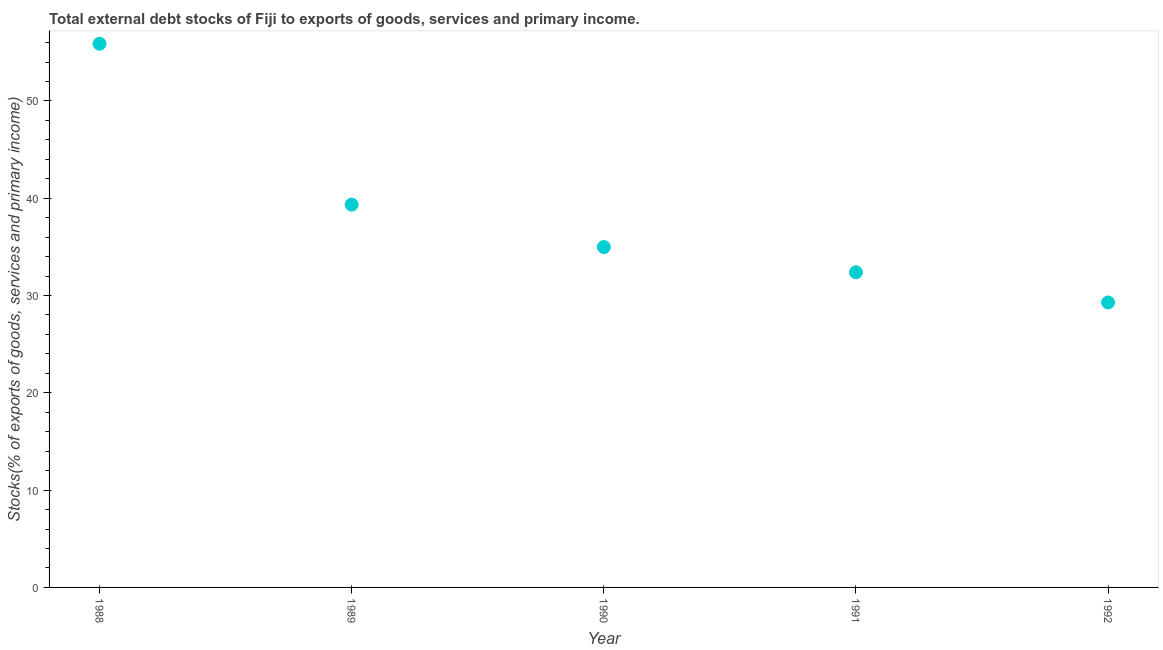What is the external debt stocks in 1989?
Provide a short and direct response. 39.34. Across all years, what is the maximum external debt stocks?
Ensure brevity in your answer.  55.88. Across all years, what is the minimum external debt stocks?
Provide a succinct answer. 29.29. In which year was the external debt stocks maximum?
Provide a succinct answer. 1988. In which year was the external debt stocks minimum?
Offer a very short reply. 1992. What is the sum of the external debt stocks?
Give a very brief answer. 191.88. What is the difference between the external debt stocks in 1991 and 1992?
Provide a succinct answer. 3.1. What is the average external debt stocks per year?
Your answer should be compact. 38.38. What is the median external debt stocks?
Your answer should be very brief. 34.98. In how many years, is the external debt stocks greater than 42 %?
Your answer should be very brief. 1. Do a majority of the years between 1991 and 1988 (inclusive) have external debt stocks greater than 22 %?
Give a very brief answer. Yes. What is the ratio of the external debt stocks in 1988 to that in 1991?
Your answer should be compact. 1.73. What is the difference between the highest and the second highest external debt stocks?
Provide a short and direct response. 16.53. Is the sum of the external debt stocks in 1990 and 1991 greater than the maximum external debt stocks across all years?
Your answer should be very brief. Yes. What is the difference between the highest and the lowest external debt stocks?
Offer a very short reply. 26.59. In how many years, is the external debt stocks greater than the average external debt stocks taken over all years?
Provide a short and direct response. 2. What is the difference between two consecutive major ticks on the Y-axis?
Offer a terse response. 10. Are the values on the major ticks of Y-axis written in scientific E-notation?
Make the answer very short. No. Does the graph contain any zero values?
Provide a succinct answer. No. What is the title of the graph?
Your answer should be compact. Total external debt stocks of Fiji to exports of goods, services and primary income. What is the label or title of the X-axis?
Give a very brief answer. Year. What is the label or title of the Y-axis?
Your response must be concise. Stocks(% of exports of goods, services and primary income). What is the Stocks(% of exports of goods, services and primary income) in 1988?
Offer a very short reply. 55.88. What is the Stocks(% of exports of goods, services and primary income) in 1989?
Offer a terse response. 39.34. What is the Stocks(% of exports of goods, services and primary income) in 1990?
Provide a short and direct response. 34.98. What is the Stocks(% of exports of goods, services and primary income) in 1991?
Offer a very short reply. 32.39. What is the Stocks(% of exports of goods, services and primary income) in 1992?
Offer a terse response. 29.29. What is the difference between the Stocks(% of exports of goods, services and primary income) in 1988 and 1989?
Your answer should be compact. 16.53. What is the difference between the Stocks(% of exports of goods, services and primary income) in 1988 and 1990?
Your response must be concise. 20.9. What is the difference between the Stocks(% of exports of goods, services and primary income) in 1988 and 1991?
Keep it short and to the point. 23.49. What is the difference between the Stocks(% of exports of goods, services and primary income) in 1988 and 1992?
Ensure brevity in your answer.  26.59. What is the difference between the Stocks(% of exports of goods, services and primary income) in 1989 and 1990?
Your answer should be compact. 4.37. What is the difference between the Stocks(% of exports of goods, services and primary income) in 1989 and 1991?
Ensure brevity in your answer.  6.95. What is the difference between the Stocks(% of exports of goods, services and primary income) in 1989 and 1992?
Your answer should be compact. 10.06. What is the difference between the Stocks(% of exports of goods, services and primary income) in 1990 and 1991?
Make the answer very short. 2.59. What is the difference between the Stocks(% of exports of goods, services and primary income) in 1990 and 1992?
Provide a short and direct response. 5.69. What is the difference between the Stocks(% of exports of goods, services and primary income) in 1991 and 1992?
Your answer should be very brief. 3.1. What is the ratio of the Stocks(% of exports of goods, services and primary income) in 1988 to that in 1989?
Your response must be concise. 1.42. What is the ratio of the Stocks(% of exports of goods, services and primary income) in 1988 to that in 1990?
Provide a short and direct response. 1.6. What is the ratio of the Stocks(% of exports of goods, services and primary income) in 1988 to that in 1991?
Offer a very short reply. 1.73. What is the ratio of the Stocks(% of exports of goods, services and primary income) in 1988 to that in 1992?
Make the answer very short. 1.91. What is the ratio of the Stocks(% of exports of goods, services and primary income) in 1989 to that in 1990?
Make the answer very short. 1.12. What is the ratio of the Stocks(% of exports of goods, services and primary income) in 1989 to that in 1991?
Your response must be concise. 1.22. What is the ratio of the Stocks(% of exports of goods, services and primary income) in 1989 to that in 1992?
Your answer should be compact. 1.34. What is the ratio of the Stocks(% of exports of goods, services and primary income) in 1990 to that in 1992?
Your response must be concise. 1.19. What is the ratio of the Stocks(% of exports of goods, services and primary income) in 1991 to that in 1992?
Make the answer very short. 1.11. 